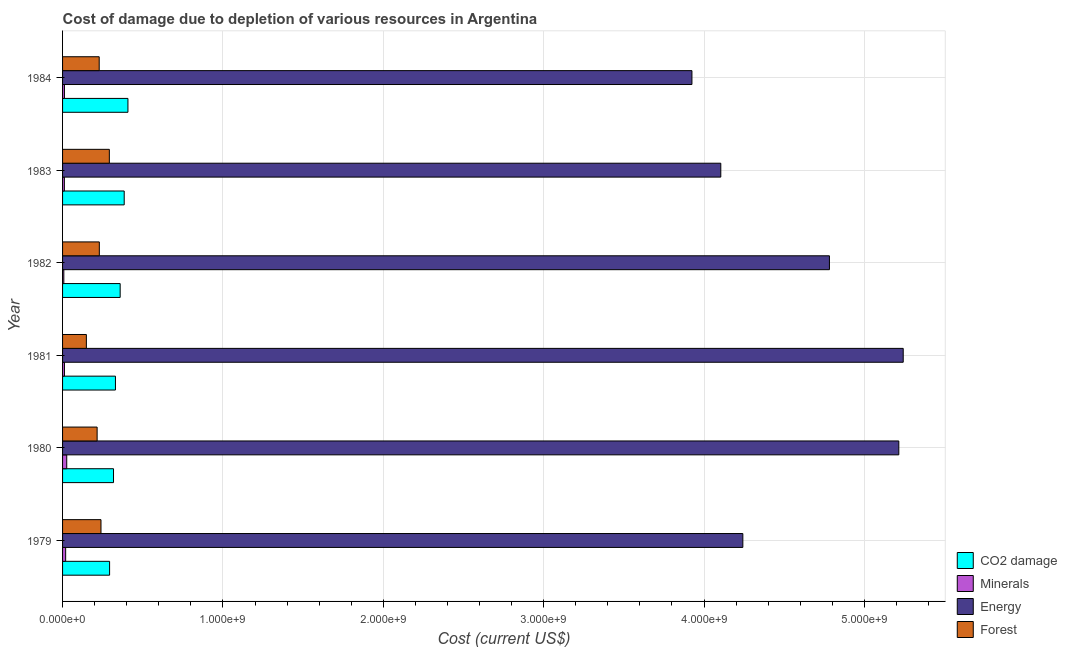How many different coloured bars are there?
Offer a very short reply. 4. Are the number of bars per tick equal to the number of legend labels?
Offer a terse response. Yes. Are the number of bars on each tick of the Y-axis equal?
Your answer should be compact. Yes. How many bars are there on the 1st tick from the top?
Offer a very short reply. 4. What is the label of the 2nd group of bars from the top?
Your answer should be compact. 1983. In how many cases, is the number of bars for a given year not equal to the number of legend labels?
Make the answer very short. 0. What is the cost of damage due to depletion of energy in 1982?
Keep it short and to the point. 4.78e+09. Across all years, what is the maximum cost of damage due to depletion of energy?
Make the answer very short. 5.24e+09. Across all years, what is the minimum cost of damage due to depletion of coal?
Offer a very short reply. 2.93e+08. In which year was the cost of damage due to depletion of coal minimum?
Give a very brief answer. 1979. What is the total cost of damage due to depletion of forests in the graph?
Your answer should be compact. 1.35e+09. What is the difference between the cost of damage due to depletion of forests in 1982 and that in 1984?
Make the answer very short. 7.38e+05. What is the difference between the cost of damage due to depletion of minerals in 1981 and the cost of damage due to depletion of forests in 1983?
Your answer should be very brief. -2.80e+08. What is the average cost of damage due to depletion of energy per year?
Your answer should be very brief. 4.58e+09. In the year 1979, what is the difference between the cost of damage due to depletion of coal and cost of damage due to depletion of energy?
Provide a succinct answer. -3.95e+09. What is the ratio of the cost of damage due to depletion of coal in 1979 to that in 1982?
Offer a very short reply. 0.82. Is the difference between the cost of damage due to depletion of energy in 1979 and 1980 greater than the difference between the cost of damage due to depletion of minerals in 1979 and 1980?
Your answer should be very brief. No. What is the difference between the highest and the second highest cost of damage due to depletion of forests?
Your answer should be compact. 5.21e+07. What is the difference between the highest and the lowest cost of damage due to depletion of forests?
Your response must be concise. 1.43e+08. Is it the case that in every year, the sum of the cost of damage due to depletion of coal and cost of damage due to depletion of forests is greater than the sum of cost of damage due to depletion of minerals and cost of damage due to depletion of energy?
Your answer should be very brief. Yes. What does the 3rd bar from the top in 1984 represents?
Make the answer very short. Minerals. What does the 4th bar from the bottom in 1981 represents?
Make the answer very short. Forest. Is it the case that in every year, the sum of the cost of damage due to depletion of coal and cost of damage due to depletion of minerals is greater than the cost of damage due to depletion of energy?
Offer a terse response. No. How many bars are there?
Your answer should be very brief. 24. Are all the bars in the graph horizontal?
Your response must be concise. Yes. How many years are there in the graph?
Make the answer very short. 6. Are the values on the major ticks of X-axis written in scientific E-notation?
Make the answer very short. Yes. Does the graph contain any zero values?
Offer a terse response. No. Does the graph contain grids?
Your response must be concise. Yes. Where does the legend appear in the graph?
Provide a short and direct response. Bottom right. How many legend labels are there?
Give a very brief answer. 4. How are the legend labels stacked?
Offer a terse response. Vertical. What is the title of the graph?
Make the answer very short. Cost of damage due to depletion of various resources in Argentina . What is the label or title of the X-axis?
Provide a succinct answer. Cost (current US$). What is the label or title of the Y-axis?
Make the answer very short. Year. What is the Cost (current US$) of CO2 damage in 1979?
Ensure brevity in your answer.  2.93e+08. What is the Cost (current US$) of Minerals in 1979?
Keep it short and to the point. 1.93e+07. What is the Cost (current US$) in Energy in 1979?
Offer a very short reply. 4.24e+09. What is the Cost (current US$) of Forest in 1979?
Your answer should be very brief. 2.40e+08. What is the Cost (current US$) of CO2 damage in 1980?
Your response must be concise. 3.18e+08. What is the Cost (current US$) in Minerals in 1980?
Ensure brevity in your answer.  2.60e+07. What is the Cost (current US$) in Energy in 1980?
Offer a very short reply. 5.21e+09. What is the Cost (current US$) in Forest in 1980?
Your response must be concise. 2.16e+08. What is the Cost (current US$) of CO2 damage in 1981?
Provide a succinct answer. 3.30e+08. What is the Cost (current US$) in Minerals in 1981?
Your response must be concise. 1.18e+07. What is the Cost (current US$) of Energy in 1981?
Provide a succinct answer. 5.24e+09. What is the Cost (current US$) of Forest in 1981?
Your answer should be compact. 1.48e+08. What is the Cost (current US$) in CO2 damage in 1982?
Make the answer very short. 3.59e+08. What is the Cost (current US$) in Minerals in 1982?
Provide a short and direct response. 7.86e+06. What is the Cost (current US$) in Energy in 1982?
Provide a succinct answer. 4.78e+09. What is the Cost (current US$) of Forest in 1982?
Keep it short and to the point. 2.29e+08. What is the Cost (current US$) of CO2 damage in 1983?
Your answer should be very brief. 3.84e+08. What is the Cost (current US$) in Minerals in 1983?
Make the answer very short. 1.12e+07. What is the Cost (current US$) of Energy in 1983?
Make the answer very short. 4.10e+09. What is the Cost (current US$) in Forest in 1983?
Give a very brief answer. 2.92e+08. What is the Cost (current US$) of CO2 damage in 1984?
Make the answer very short. 4.08e+08. What is the Cost (current US$) of Minerals in 1984?
Ensure brevity in your answer.  1.17e+07. What is the Cost (current US$) in Energy in 1984?
Provide a succinct answer. 3.92e+09. What is the Cost (current US$) in Forest in 1984?
Your answer should be very brief. 2.28e+08. Across all years, what is the maximum Cost (current US$) in CO2 damage?
Offer a terse response. 4.08e+08. Across all years, what is the maximum Cost (current US$) in Minerals?
Make the answer very short. 2.60e+07. Across all years, what is the maximum Cost (current US$) of Energy?
Keep it short and to the point. 5.24e+09. Across all years, what is the maximum Cost (current US$) in Forest?
Ensure brevity in your answer.  2.92e+08. Across all years, what is the minimum Cost (current US$) of CO2 damage?
Keep it short and to the point. 2.93e+08. Across all years, what is the minimum Cost (current US$) of Minerals?
Give a very brief answer. 7.86e+06. Across all years, what is the minimum Cost (current US$) of Energy?
Provide a short and direct response. 3.92e+09. Across all years, what is the minimum Cost (current US$) in Forest?
Make the answer very short. 1.48e+08. What is the total Cost (current US$) in CO2 damage in the graph?
Your answer should be very brief. 2.09e+09. What is the total Cost (current US$) in Minerals in the graph?
Offer a terse response. 8.79e+07. What is the total Cost (current US$) of Energy in the graph?
Provide a succinct answer. 2.75e+1. What is the total Cost (current US$) of Forest in the graph?
Keep it short and to the point. 1.35e+09. What is the difference between the Cost (current US$) in CO2 damage in 1979 and that in 1980?
Offer a very short reply. -2.45e+07. What is the difference between the Cost (current US$) in Minerals in 1979 and that in 1980?
Offer a very short reply. -6.76e+06. What is the difference between the Cost (current US$) of Energy in 1979 and that in 1980?
Your response must be concise. -9.73e+08. What is the difference between the Cost (current US$) in Forest in 1979 and that in 1980?
Provide a short and direct response. 2.41e+07. What is the difference between the Cost (current US$) of CO2 damage in 1979 and that in 1981?
Ensure brevity in your answer.  -3.66e+07. What is the difference between the Cost (current US$) of Minerals in 1979 and that in 1981?
Provide a short and direct response. 7.51e+06. What is the difference between the Cost (current US$) of Energy in 1979 and that in 1981?
Your answer should be very brief. -1.00e+09. What is the difference between the Cost (current US$) of Forest in 1979 and that in 1981?
Provide a short and direct response. 9.11e+07. What is the difference between the Cost (current US$) in CO2 damage in 1979 and that in 1982?
Offer a very short reply. -6.59e+07. What is the difference between the Cost (current US$) in Minerals in 1979 and that in 1982?
Your answer should be very brief. 1.14e+07. What is the difference between the Cost (current US$) of Energy in 1979 and that in 1982?
Your answer should be compact. -5.40e+08. What is the difference between the Cost (current US$) in Forest in 1979 and that in 1982?
Offer a terse response. 1.04e+07. What is the difference between the Cost (current US$) of CO2 damage in 1979 and that in 1983?
Keep it short and to the point. -9.11e+07. What is the difference between the Cost (current US$) of Minerals in 1979 and that in 1983?
Offer a very short reply. 8.03e+06. What is the difference between the Cost (current US$) of Energy in 1979 and that in 1983?
Your response must be concise. 1.37e+08. What is the difference between the Cost (current US$) in Forest in 1979 and that in 1983?
Ensure brevity in your answer.  -5.21e+07. What is the difference between the Cost (current US$) of CO2 damage in 1979 and that in 1984?
Your response must be concise. -1.14e+08. What is the difference between the Cost (current US$) of Minerals in 1979 and that in 1984?
Provide a succinct answer. 7.57e+06. What is the difference between the Cost (current US$) of Energy in 1979 and that in 1984?
Your answer should be very brief. 3.17e+08. What is the difference between the Cost (current US$) of Forest in 1979 and that in 1984?
Offer a very short reply. 1.11e+07. What is the difference between the Cost (current US$) of CO2 damage in 1980 and that in 1981?
Make the answer very short. -1.21e+07. What is the difference between the Cost (current US$) of Minerals in 1980 and that in 1981?
Offer a terse response. 1.43e+07. What is the difference between the Cost (current US$) of Energy in 1980 and that in 1981?
Give a very brief answer. -2.75e+07. What is the difference between the Cost (current US$) of Forest in 1980 and that in 1981?
Provide a short and direct response. 6.71e+07. What is the difference between the Cost (current US$) in CO2 damage in 1980 and that in 1982?
Ensure brevity in your answer.  -4.15e+07. What is the difference between the Cost (current US$) of Minerals in 1980 and that in 1982?
Ensure brevity in your answer.  1.82e+07. What is the difference between the Cost (current US$) in Energy in 1980 and that in 1982?
Make the answer very short. 4.33e+08. What is the difference between the Cost (current US$) in Forest in 1980 and that in 1982?
Offer a very short reply. -1.37e+07. What is the difference between the Cost (current US$) in CO2 damage in 1980 and that in 1983?
Offer a terse response. -6.66e+07. What is the difference between the Cost (current US$) in Minerals in 1980 and that in 1983?
Keep it short and to the point. 1.48e+07. What is the difference between the Cost (current US$) of Energy in 1980 and that in 1983?
Provide a succinct answer. 1.11e+09. What is the difference between the Cost (current US$) of Forest in 1980 and that in 1983?
Your response must be concise. -7.62e+07. What is the difference between the Cost (current US$) of CO2 damage in 1980 and that in 1984?
Offer a very short reply. -8.99e+07. What is the difference between the Cost (current US$) in Minerals in 1980 and that in 1984?
Keep it short and to the point. 1.43e+07. What is the difference between the Cost (current US$) of Energy in 1980 and that in 1984?
Give a very brief answer. 1.29e+09. What is the difference between the Cost (current US$) of Forest in 1980 and that in 1984?
Your response must be concise. -1.30e+07. What is the difference between the Cost (current US$) in CO2 damage in 1981 and that in 1982?
Offer a terse response. -2.94e+07. What is the difference between the Cost (current US$) of Minerals in 1981 and that in 1982?
Your response must be concise. 3.91e+06. What is the difference between the Cost (current US$) of Energy in 1981 and that in 1982?
Your response must be concise. 4.60e+08. What is the difference between the Cost (current US$) in Forest in 1981 and that in 1982?
Keep it short and to the point. -8.08e+07. What is the difference between the Cost (current US$) of CO2 damage in 1981 and that in 1983?
Provide a succinct answer. -5.45e+07. What is the difference between the Cost (current US$) of Minerals in 1981 and that in 1983?
Provide a succinct answer. 5.26e+05. What is the difference between the Cost (current US$) in Energy in 1981 and that in 1983?
Provide a short and direct response. 1.14e+09. What is the difference between the Cost (current US$) of Forest in 1981 and that in 1983?
Make the answer very short. -1.43e+08. What is the difference between the Cost (current US$) in CO2 damage in 1981 and that in 1984?
Make the answer very short. -7.78e+07. What is the difference between the Cost (current US$) of Minerals in 1981 and that in 1984?
Keep it short and to the point. 6.34e+04. What is the difference between the Cost (current US$) of Energy in 1981 and that in 1984?
Provide a succinct answer. 1.32e+09. What is the difference between the Cost (current US$) in Forest in 1981 and that in 1984?
Make the answer very short. -8.00e+07. What is the difference between the Cost (current US$) in CO2 damage in 1982 and that in 1983?
Provide a succinct answer. -2.51e+07. What is the difference between the Cost (current US$) in Minerals in 1982 and that in 1983?
Your response must be concise. -3.38e+06. What is the difference between the Cost (current US$) in Energy in 1982 and that in 1983?
Make the answer very short. 6.77e+08. What is the difference between the Cost (current US$) in Forest in 1982 and that in 1983?
Give a very brief answer. -6.25e+07. What is the difference between the Cost (current US$) of CO2 damage in 1982 and that in 1984?
Provide a short and direct response. -4.84e+07. What is the difference between the Cost (current US$) in Minerals in 1982 and that in 1984?
Provide a succinct answer. -3.84e+06. What is the difference between the Cost (current US$) in Energy in 1982 and that in 1984?
Make the answer very short. 8.57e+08. What is the difference between the Cost (current US$) of Forest in 1982 and that in 1984?
Give a very brief answer. 7.38e+05. What is the difference between the Cost (current US$) of CO2 damage in 1983 and that in 1984?
Offer a terse response. -2.33e+07. What is the difference between the Cost (current US$) in Minerals in 1983 and that in 1984?
Offer a terse response. -4.63e+05. What is the difference between the Cost (current US$) in Energy in 1983 and that in 1984?
Give a very brief answer. 1.80e+08. What is the difference between the Cost (current US$) of Forest in 1983 and that in 1984?
Keep it short and to the point. 6.32e+07. What is the difference between the Cost (current US$) of CO2 damage in 1979 and the Cost (current US$) of Minerals in 1980?
Offer a terse response. 2.67e+08. What is the difference between the Cost (current US$) of CO2 damage in 1979 and the Cost (current US$) of Energy in 1980?
Give a very brief answer. -4.92e+09. What is the difference between the Cost (current US$) of CO2 damage in 1979 and the Cost (current US$) of Forest in 1980?
Keep it short and to the point. 7.77e+07. What is the difference between the Cost (current US$) in Minerals in 1979 and the Cost (current US$) in Energy in 1980?
Offer a very short reply. -5.20e+09. What is the difference between the Cost (current US$) of Minerals in 1979 and the Cost (current US$) of Forest in 1980?
Offer a terse response. -1.96e+08. What is the difference between the Cost (current US$) of Energy in 1979 and the Cost (current US$) of Forest in 1980?
Ensure brevity in your answer.  4.03e+09. What is the difference between the Cost (current US$) of CO2 damage in 1979 and the Cost (current US$) of Minerals in 1981?
Provide a short and direct response. 2.81e+08. What is the difference between the Cost (current US$) in CO2 damage in 1979 and the Cost (current US$) in Energy in 1981?
Offer a very short reply. -4.95e+09. What is the difference between the Cost (current US$) of CO2 damage in 1979 and the Cost (current US$) of Forest in 1981?
Give a very brief answer. 1.45e+08. What is the difference between the Cost (current US$) in Minerals in 1979 and the Cost (current US$) in Energy in 1981?
Provide a succinct answer. -5.22e+09. What is the difference between the Cost (current US$) of Minerals in 1979 and the Cost (current US$) of Forest in 1981?
Your answer should be compact. -1.29e+08. What is the difference between the Cost (current US$) of Energy in 1979 and the Cost (current US$) of Forest in 1981?
Keep it short and to the point. 4.09e+09. What is the difference between the Cost (current US$) in CO2 damage in 1979 and the Cost (current US$) in Minerals in 1982?
Make the answer very short. 2.85e+08. What is the difference between the Cost (current US$) of CO2 damage in 1979 and the Cost (current US$) of Energy in 1982?
Ensure brevity in your answer.  -4.49e+09. What is the difference between the Cost (current US$) in CO2 damage in 1979 and the Cost (current US$) in Forest in 1982?
Give a very brief answer. 6.41e+07. What is the difference between the Cost (current US$) in Minerals in 1979 and the Cost (current US$) in Energy in 1982?
Your answer should be compact. -4.76e+09. What is the difference between the Cost (current US$) in Minerals in 1979 and the Cost (current US$) in Forest in 1982?
Your answer should be compact. -2.10e+08. What is the difference between the Cost (current US$) in Energy in 1979 and the Cost (current US$) in Forest in 1982?
Make the answer very short. 4.01e+09. What is the difference between the Cost (current US$) of CO2 damage in 1979 and the Cost (current US$) of Minerals in 1983?
Your response must be concise. 2.82e+08. What is the difference between the Cost (current US$) in CO2 damage in 1979 and the Cost (current US$) in Energy in 1983?
Your response must be concise. -3.81e+09. What is the difference between the Cost (current US$) in CO2 damage in 1979 and the Cost (current US$) in Forest in 1983?
Offer a very short reply. 1.58e+06. What is the difference between the Cost (current US$) in Minerals in 1979 and the Cost (current US$) in Energy in 1983?
Provide a short and direct response. -4.09e+09. What is the difference between the Cost (current US$) of Minerals in 1979 and the Cost (current US$) of Forest in 1983?
Give a very brief answer. -2.72e+08. What is the difference between the Cost (current US$) in Energy in 1979 and the Cost (current US$) in Forest in 1983?
Your response must be concise. 3.95e+09. What is the difference between the Cost (current US$) of CO2 damage in 1979 and the Cost (current US$) of Minerals in 1984?
Offer a terse response. 2.82e+08. What is the difference between the Cost (current US$) of CO2 damage in 1979 and the Cost (current US$) of Energy in 1984?
Your answer should be compact. -3.63e+09. What is the difference between the Cost (current US$) of CO2 damage in 1979 and the Cost (current US$) of Forest in 1984?
Make the answer very short. 6.48e+07. What is the difference between the Cost (current US$) of Minerals in 1979 and the Cost (current US$) of Energy in 1984?
Provide a succinct answer. -3.91e+09. What is the difference between the Cost (current US$) of Minerals in 1979 and the Cost (current US$) of Forest in 1984?
Your response must be concise. -2.09e+08. What is the difference between the Cost (current US$) in Energy in 1979 and the Cost (current US$) in Forest in 1984?
Ensure brevity in your answer.  4.01e+09. What is the difference between the Cost (current US$) of CO2 damage in 1980 and the Cost (current US$) of Minerals in 1981?
Your response must be concise. 3.06e+08. What is the difference between the Cost (current US$) of CO2 damage in 1980 and the Cost (current US$) of Energy in 1981?
Your answer should be compact. -4.92e+09. What is the difference between the Cost (current US$) in CO2 damage in 1980 and the Cost (current US$) in Forest in 1981?
Offer a very short reply. 1.69e+08. What is the difference between the Cost (current US$) of Minerals in 1980 and the Cost (current US$) of Energy in 1981?
Your response must be concise. -5.22e+09. What is the difference between the Cost (current US$) in Minerals in 1980 and the Cost (current US$) in Forest in 1981?
Offer a very short reply. -1.22e+08. What is the difference between the Cost (current US$) of Energy in 1980 and the Cost (current US$) of Forest in 1981?
Your answer should be very brief. 5.07e+09. What is the difference between the Cost (current US$) in CO2 damage in 1980 and the Cost (current US$) in Minerals in 1982?
Your answer should be compact. 3.10e+08. What is the difference between the Cost (current US$) in CO2 damage in 1980 and the Cost (current US$) in Energy in 1982?
Your answer should be compact. -4.46e+09. What is the difference between the Cost (current US$) of CO2 damage in 1980 and the Cost (current US$) of Forest in 1982?
Provide a succinct answer. 8.85e+07. What is the difference between the Cost (current US$) in Minerals in 1980 and the Cost (current US$) in Energy in 1982?
Provide a short and direct response. -4.76e+09. What is the difference between the Cost (current US$) in Minerals in 1980 and the Cost (current US$) in Forest in 1982?
Provide a short and direct response. -2.03e+08. What is the difference between the Cost (current US$) in Energy in 1980 and the Cost (current US$) in Forest in 1982?
Offer a very short reply. 4.99e+09. What is the difference between the Cost (current US$) of CO2 damage in 1980 and the Cost (current US$) of Minerals in 1983?
Give a very brief answer. 3.06e+08. What is the difference between the Cost (current US$) in CO2 damage in 1980 and the Cost (current US$) in Energy in 1983?
Keep it short and to the point. -3.79e+09. What is the difference between the Cost (current US$) of CO2 damage in 1980 and the Cost (current US$) of Forest in 1983?
Make the answer very short. 2.60e+07. What is the difference between the Cost (current US$) of Minerals in 1980 and the Cost (current US$) of Energy in 1983?
Give a very brief answer. -4.08e+09. What is the difference between the Cost (current US$) of Minerals in 1980 and the Cost (current US$) of Forest in 1983?
Provide a succinct answer. -2.66e+08. What is the difference between the Cost (current US$) of Energy in 1980 and the Cost (current US$) of Forest in 1983?
Your response must be concise. 4.92e+09. What is the difference between the Cost (current US$) in CO2 damage in 1980 and the Cost (current US$) in Minerals in 1984?
Make the answer very short. 3.06e+08. What is the difference between the Cost (current US$) in CO2 damage in 1980 and the Cost (current US$) in Energy in 1984?
Provide a succinct answer. -3.61e+09. What is the difference between the Cost (current US$) in CO2 damage in 1980 and the Cost (current US$) in Forest in 1984?
Ensure brevity in your answer.  8.93e+07. What is the difference between the Cost (current US$) in Minerals in 1980 and the Cost (current US$) in Energy in 1984?
Give a very brief answer. -3.90e+09. What is the difference between the Cost (current US$) in Minerals in 1980 and the Cost (current US$) in Forest in 1984?
Provide a succinct answer. -2.02e+08. What is the difference between the Cost (current US$) of Energy in 1980 and the Cost (current US$) of Forest in 1984?
Provide a succinct answer. 4.99e+09. What is the difference between the Cost (current US$) in CO2 damage in 1981 and the Cost (current US$) in Minerals in 1982?
Ensure brevity in your answer.  3.22e+08. What is the difference between the Cost (current US$) of CO2 damage in 1981 and the Cost (current US$) of Energy in 1982?
Provide a succinct answer. -4.45e+09. What is the difference between the Cost (current US$) of CO2 damage in 1981 and the Cost (current US$) of Forest in 1982?
Make the answer very short. 1.01e+08. What is the difference between the Cost (current US$) of Minerals in 1981 and the Cost (current US$) of Energy in 1982?
Provide a succinct answer. -4.77e+09. What is the difference between the Cost (current US$) in Minerals in 1981 and the Cost (current US$) in Forest in 1982?
Provide a short and direct response. -2.17e+08. What is the difference between the Cost (current US$) of Energy in 1981 and the Cost (current US$) of Forest in 1982?
Provide a short and direct response. 5.01e+09. What is the difference between the Cost (current US$) of CO2 damage in 1981 and the Cost (current US$) of Minerals in 1983?
Your answer should be compact. 3.19e+08. What is the difference between the Cost (current US$) of CO2 damage in 1981 and the Cost (current US$) of Energy in 1983?
Provide a short and direct response. -3.77e+09. What is the difference between the Cost (current US$) of CO2 damage in 1981 and the Cost (current US$) of Forest in 1983?
Keep it short and to the point. 3.81e+07. What is the difference between the Cost (current US$) of Minerals in 1981 and the Cost (current US$) of Energy in 1983?
Offer a very short reply. -4.09e+09. What is the difference between the Cost (current US$) in Minerals in 1981 and the Cost (current US$) in Forest in 1983?
Offer a terse response. -2.80e+08. What is the difference between the Cost (current US$) of Energy in 1981 and the Cost (current US$) of Forest in 1983?
Provide a succinct answer. 4.95e+09. What is the difference between the Cost (current US$) of CO2 damage in 1981 and the Cost (current US$) of Minerals in 1984?
Provide a succinct answer. 3.18e+08. What is the difference between the Cost (current US$) in CO2 damage in 1981 and the Cost (current US$) in Energy in 1984?
Your answer should be very brief. -3.59e+09. What is the difference between the Cost (current US$) in CO2 damage in 1981 and the Cost (current US$) in Forest in 1984?
Your response must be concise. 1.01e+08. What is the difference between the Cost (current US$) in Minerals in 1981 and the Cost (current US$) in Energy in 1984?
Provide a succinct answer. -3.91e+09. What is the difference between the Cost (current US$) in Minerals in 1981 and the Cost (current US$) in Forest in 1984?
Provide a succinct answer. -2.17e+08. What is the difference between the Cost (current US$) of Energy in 1981 and the Cost (current US$) of Forest in 1984?
Keep it short and to the point. 5.01e+09. What is the difference between the Cost (current US$) in CO2 damage in 1982 and the Cost (current US$) in Minerals in 1983?
Give a very brief answer. 3.48e+08. What is the difference between the Cost (current US$) in CO2 damage in 1982 and the Cost (current US$) in Energy in 1983?
Keep it short and to the point. -3.75e+09. What is the difference between the Cost (current US$) in CO2 damage in 1982 and the Cost (current US$) in Forest in 1983?
Your answer should be compact. 6.75e+07. What is the difference between the Cost (current US$) in Minerals in 1982 and the Cost (current US$) in Energy in 1983?
Your response must be concise. -4.10e+09. What is the difference between the Cost (current US$) in Minerals in 1982 and the Cost (current US$) in Forest in 1983?
Your response must be concise. -2.84e+08. What is the difference between the Cost (current US$) of Energy in 1982 and the Cost (current US$) of Forest in 1983?
Your response must be concise. 4.49e+09. What is the difference between the Cost (current US$) of CO2 damage in 1982 and the Cost (current US$) of Minerals in 1984?
Your answer should be very brief. 3.48e+08. What is the difference between the Cost (current US$) of CO2 damage in 1982 and the Cost (current US$) of Energy in 1984?
Offer a very short reply. -3.57e+09. What is the difference between the Cost (current US$) of CO2 damage in 1982 and the Cost (current US$) of Forest in 1984?
Ensure brevity in your answer.  1.31e+08. What is the difference between the Cost (current US$) of Minerals in 1982 and the Cost (current US$) of Energy in 1984?
Your response must be concise. -3.92e+09. What is the difference between the Cost (current US$) of Minerals in 1982 and the Cost (current US$) of Forest in 1984?
Offer a terse response. -2.21e+08. What is the difference between the Cost (current US$) in Energy in 1982 and the Cost (current US$) in Forest in 1984?
Give a very brief answer. 4.55e+09. What is the difference between the Cost (current US$) in CO2 damage in 1983 and the Cost (current US$) in Minerals in 1984?
Give a very brief answer. 3.73e+08. What is the difference between the Cost (current US$) of CO2 damage in 1983 and the Cost (current US$) of Energy in 1984?
Your answer should be compact. -3.54e+09. What is the difference between the Cost (current US$) in CO2 damage in 1983 and the Cost (current US$) in Forest in 1984?
Give a very brief answer. 1.56e+08. What is the difference between the Cost (current US$) in Minerals in 1983 and the Cost (current US$) in Energy in 1984?
Offer a terse response. -3.91e+09. What is the difference between the Cost (current US$) in Minerals in 1983 and the Cost (current US$) in Forest in 1984?
Provide a short and direct response. -2.17e+08. What is the difference between the Cost (current US$) in Energy in 1983 and the Cost (current US$) in Forest in 1984?
Give a very brief answer. 3.88e+09. What is the average Cost (current US$) in CO2 damage per year?
Offer a terse response. 3.49e+08. What is the average Cost (current US$) in Minerals per year?
Provide a succinct answer. 1.46e+07. What is the average Cost (current US$) in Energy per year?
Ensure brevity in your answer.  4.58e+09. What is the average Cost (current US$) in Forest per year?
Offer a very short reply. 2.25e+08. In the year 1979, what is the difference between the Cost (current US$) in CO2 damage and Cost (current US$) in Minerals?
Your answer should be very brief. 2.74e+08. In the year 1979, what is the difference between the Cost (current US$) of CO2 damage and Cost (current US$) of Energy?
Provide a short and direct response. -3.95e+09. In the year 1979, what is the difference between the Cost (current US$) of CO2 damage and Cost (current US$) of Forest?
Provide a short and direct response. 5.37e+07. In the year 1979, what is the difference between the Cost (current US$) of Minerals and Cost (current US$) of Energy?
Make the answer very short. -4.22e+09. In the year 1979, what is the difference between the Cost (current US$) of Minerals and Cost (current US$) of Forest?
Make the answer very short. -2.20e+08. In the year 1979, what is the difference between the Cost (current US$) of Energy and Cost (current US$) of Forest?
Your response must be concise. 4.00e+09. In the year 1980, what is the difference between the Cost (current US$) of CO2 damage and Cost (current US$) of Minerals?
Offer a terse response. 2.92e+08. In the year 1980, what is the difference between the Cost (current US$) in CO2 damage and Cost (current US$) in Energy?
Your answer should be very brief. -4.90e+09. In the year 1980, what is the difference between the Cost (current US$) of CO2 damage and Cost (current US$) of Forest?
Provide a short and direct response. 1.02e+08. In the year 1980, what is the difference between the Cost (current US$) of Minerals and Cost (current US$) of Energy?
Offer a very short reply. -5.19e+09. In the year 1980, what is the difference between the Cost (current US$) of Minerals and Cost (current US$) of Forest?
Your answer should be compact. -1.89e+08. In the year 1980, what is the difference between the Cost (current US$) in Energy and Cost (current US$) in Forest?
Offer a terse response. 5.00e+09. In the year 1981, what is the difference between the Cost (current US$) in CO2 damage and Cost (current US$) in Minerals?
Your answer should be very brief. 3.18e+08. In the year 1981, what is the difference between the Cost (current US$) in CO2 damage and Cost (current US$) in Energy?
Offer a terse response. -4.91e+09. In the year 1981, what is the difference between the Cost (current US$) in CO2 damage and Cost (current US$) in Forest?
Give a very brief answer. 1.81e+08. In the year 1981, what is the difference between the Cost (current US$) of Minerals and Cost (current US$) of Energy?
Make the answer very short. -5.23e+09. In the year 1981, what is the difference between the Cost (current US$) in Minerals and Cost (current US$) in Forest?
Make the answer very short. -1.37e+08. In the year 1981, what is the difference between the Cost (current US$) in Energy and Cost (current US$) in Forest?
Give a very brief answer. 5.09e+09. In the year 1982, what is the difference between the Cost (current US$) of CO2 damage and Cost (current US$) of Minerals?
Offer a very short reply. 3.51e+08. In the year 1982, what is the difference between the Cost (current US$) in CO2 damage and Cost (current US$) in Energy?
Offer a terse response. -4.42e+09. In the year 1982, what is the difference between the Cost (current US$) in CO2 damage and Cost (current US$) in Forest?
Your answer should be compact. 1.30e+08. In the year 1982, what is the difference between the Cost (current US$) of Minerals and Cost (current US$) of Energy?
Your response must be concise. -4.77e+09. In the year 1982, what is the difference between the Cost (current US$) of Minerals and Cost (current US$) of Forest?
Keep it short and to the point. -2.21e+08. In the year 1982, what is the difference between the Cost (current US$) in Energy and Cost (current US$) in Forest?
Your answer should be very brief. 4.55e+09. In the year 1983, what is the difference between the Cost (current US$) in CO2 damage and Cost (current US$) in Minerals?
Offer a terse response. 3.73e+08. In the year 1983, what is the difference between the Cost (current US$) of CO2 damage and Cost (current US$) of Energy?
Your answer should be compact. -3.72e+09. In the year 1983, what is the difference between the Cost (current US$) in CO2 damage and Cost (current US$) in Forest?
Your answer should be compact. 9.26e+07. In the year 1983, what is the difference between the Cost (current US$) of Minerals and Cost (current US$) of Energy?
Provide a short and direct response. -4.09e+09. In the year 1983, what is the difference between the Cost (current US$) of Minerals and Cost (current US$) of Forest?
Keep it short and to the point. -2.80e+08. In the year 1983, what is the difference between the Cost (current US$) in Energy and Cost (current US$) in Forest?
Keep it short and to the point. 3.81e+09. In the year 1984, what is the difference between the Cost (current US$) of CO2 damage and Cost (current US$) of Minerals?
Give a very brief answer. 3.96e+08. In the year 1984, what is the difference between the Cost (current US$) in CO2 damage and Cost (current US$) in Energy?
Ensure brevity in your answer.  -3.52e+09. In the year 1984, what is the difference between the Cost (current US$) of CO2 damage and Cost (current US$) of Forest?
Offer a terse response. 1.79e+08. In the year 1984, what is the difference between the Cost (current US$) of Minerals and Cost (current US$) of Energy?
Provide a short and direct response. -3.91e+09. In the year 1984, what is the difference between the Cost (current US$) of Minerals and Cost (current US$) of Forest?
Your answer should be very brief. -2.17e+08. In the year 1984, what is the difference between the Cost (current US$) in Energy and Cost (current US$) in Forest?
Provide a short and direct response. 3.70e+09. What is the ratio of the Cost (current US$) of CO2 damage in 1979 to that in 1980?
Offer a terse response. 0.92. What is the ratio of the Cost (current US$) in Minerals in 1979 to that in 1980?
Provide a succinct answer. 0.74. What is the ratio of the Cost (current US$) in Energy in 1979 to that in 1980?
Keep it short and to the point. 0.81. What is the ratio of the Cost (current US$) of Forest in 1979 to that in 1980?
Make the answer very short. 1.11. What is the ratio of the Cost (current US$) of CO2 damage in 1979 to that in 1981?
Keep it short and to the point. 0.89. What is the ratio of the Cost (current US$) of Minerals in 1979 to that in 1981?
Provide a short and direct response. 1.64. What is the ratio of the Cost (current US$) of Energy in 1979 to that in 1981?
Give a very brief answer. 0.81. What is the ratio of the Cost (current US$) in Forest in 1979 to that in 1981?
Keep it short and to the point. 1.61. What is the ratio of the Cost (current US$) in CO2 damage in 1979 to that in 1982?
Offer a very short reply. 0.82. What is the ratio of the Cost (current US$) of Minerals in 1979 to that in 1982?
Keep it short and to the point. 2.45. What is the ratio of the Cost (current US$) in Energy in 1979 to that in 1982?
Your answer should be compact. 0.89. What is the ratio of the Cost (current US$) of Forest in 1979 to that in 1982?
Give a very brief answer. 1.05. What is the ratio of the Cost (current US$) of CO2 damage in 1979 to that in 1983?
Offer a terse response. 0.76. What is the ratio of the Cost (current US$) of Minerals in 1979 to that in 1983?
Make the answer very short. 1.71. What is the ratio of the Cost (current US$) in Energy in 1979 to that in 1983?
Give a very brief answer. 1.03. What is the ratio of the Cost (current US$) of Forest in 1979 to that in 1983?
Your answer should be compact. 0.82. What is the ratio of the Cost (current US$) of CO2 damage in 1979 to that in 1984?
Provide a short and direct response. 0.72. What is the ratio of the Cost (current US$) of Minerals in 1979 to that in 1984?
Make the answer very short. 1.65. What is the ratio of the Cost (current US$) of Energy in 1979 to that in 1984?
Your answer should be compact. 1.08. What is the ratio of the Cost (current US$) in Forest in 1979 to that in 1984?
Offer a very short reply. 1.05. What is the ratio of the Cost (current US$) of CO2 damage in 1980 to that in 1981?
Make the answer very short. 0.96. What is the ratio of the Cost (current US$) in Minerals in 1980 to that in 1981?
Make the answer very short. 2.21. What is the ratio of the Cost (current US$) of Energy in 1980 to that in 1981?
Your answer should be very brief. 0.99. What is the ratio of the Cost (current US$) of Forest in 1980 to that in 1981?
Your response must be concise. 1.45. What is the ratio of the Cost (current US$) of CO2 damage in 1980 to that in 1982?
Provide a short and direct response. 0.88. What is the ratio of the Cost (current US$) of Minerals in 1980 to that in 1982?
Keep it short and to the point. 3.31. What is the ratio of the Cost (current US$) of Energy in 1980 to that in 1982?
Provide a succinct answer. 1.09. What is the ratio of the Cost (current US$) of Forest in 1980 to that in 1982?
Keep it short and to the point. 0.94. What is the ratio of the Cost (current US$) in CO2 damage in 1980 to that in 1983?
Offer a terse response. 0.83. What is the ratio of the Cost (current US$) of Minerals in 1980 to that in 1983?
Your answer should be compact. 2.32. What is the ratio of the Cost (current US$) of Energy in 1980 to that in 1983?
Give a very brief answer. 1.27. What is the ratio of the Cost (current US$) in Forest in 1980 to that in 1983?
Your answer should be very brief. 0.74. What is the ratio of the Cost (current US$) in CO2 damage in 1980 to that in 1984?
Keep it short and to the point. 0.78. What is the ratio of the Cost (current US$) in Minerals in 1980 to that in 1984?
Your answer should be very brief. 2.22. What is the ratio of the Cost (current US$) of Energy in 1980 to that in 1984?
Your answer should be compact. 1.33. What is the ratio of the Cost (current US$) in Forest in 1980 to that in 1984?
Provide a short and direct response. 0.94. What is the ratio of the Cost (current US$) of CO2 damage in 1981 to that in 1982?
Offer a very short reply. 0.92. What is the ratio of the Cost (current US$) of Minerals in 1981 to that in 1982?
Your response must be concise. 1.5. What is the ratio of the Cost (current US$) of Energy in 1981 to that in 1982?
Make the answer very short. 1.1. What is the ratio of the Cost (current US$) in Forest in 1981 to that in 1982?
Give a very brief answer. 0.65. What is the ratio of the Cost (current US$) in CO2 damage in 1981 to that in 1983?
Keep it short and to the point. 0.86. What is the ratio of the Cost (current US$) of Minerals in 1981 to that in 1983?
Offer a terse response. 1.05. What is the ratio of the Cost (current US$) in Energy in 1981 to that in 1983?
Make the answer very short. 1.28. What is the ratio of the Cost (current US$) of Forest in 1981 to that in 1983?
Give a very brief answer. 0.51. What is the ratio of the Cost (current US$) in CO2 damage in 1981 to that in 1984?
Provide a succinct answer. 0.81. What is the ratio of the Cost (current US$) in Minerals in 1981 to that in 1984?
Make the answer very short. 1.01. What is the ratio of the Cost (current US$) in Energy in 1981 to that in 1984?
Offer a very short reply. 1.34. What is the ratio of the Cost (current US$) in Forest in 1981 to that in 1984?
Your answer should be very brief. 0.65. What is the ratio of the Cost (current US$) of CO2 damage in 1982 to that in 1983?
Provide a succinct answer. 0.93. What is the ratio of the Cost (current US$) of Minerals in 1982 to that in 1983?
Provide a short and direct response. 0.7. What is the ratio of the Cost (current US$) in Energy in 1982 to that in 1983?
Keep it short and to the point. 1.17. What is the ratio of the Cost (current US$) in Forest in 1982 to that in 1983?
Your response must be concise. 0.79. What is the ratio of the Cost (current US$) of CO2 damage in 1982 to that in 1984?
Keep it short and to the point. 0.88. What is the ratio of the Cost (current US$) of Minerals in 1982 to that in 1984?
Your response must be concise. 0.67. What is the ratio of the Cost (current US$) of Energy in 1982 to that in 1984?
Offer a terse response. 1.22. What is the ratio of the Cost (current US$) in CO2 damage in 1983 to that in 1984?
Offer a very short reply. 0.94. What is the ratio of the Cost (current US$) of Minerals in 1983 to that in 1984?
Make the answer very short. 0.96. What is the ratio of the Cost (current US$) in Energy in 1983 to that in 1984?
Offer a very short reply. 1.05. What is the ratio of the Cost (current US$) in Forest in 1983 to that in 1984?
Offer a terse response. 1.28. What is the difference between the highest and the second highest Cost (current US$) in CO2 damage?
Provide a succinct answer. 2.33e+07. What is the difference between the highest and the second highest Cost (current US$) of Minerals?
Offer a terse response. 6.76e+06. What is the difference between the highest and the second highest Cost (current US$) of Energy?
Offer a very short reply. 2.75e+07. What is the difference between the highest and the second highest Cost (current US$) of Forest?
Your answer should be compact. 5.21e+07. What is the difference between the highest and the lowest Cost (current US$) of CO2 damage?
Ensure brevity in your answer.  1.14e+08. What is the difference between the highest and the lowest Cost (current US$) of Minerals?
Keep it short and to the point. 1.82e+07. What is the difference between the highest and the lowest Cost (current US$) in Energy?
Your answer should be compact. 1.32e+09. What is the difference between the highest and the lowest Cost (current US$) of Forest?
Your answer should be very brief. 1.43e+08. 